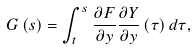<formula> <loc_0><loc_0><loc_500><loc_500>G \left ( s \right ) = \int _ { t } ^ { s } \frac { \partial F } { \partial y } \frac { \partial Y } { \partial y } \left ( \tau \right ) d \tau ,</formula> 